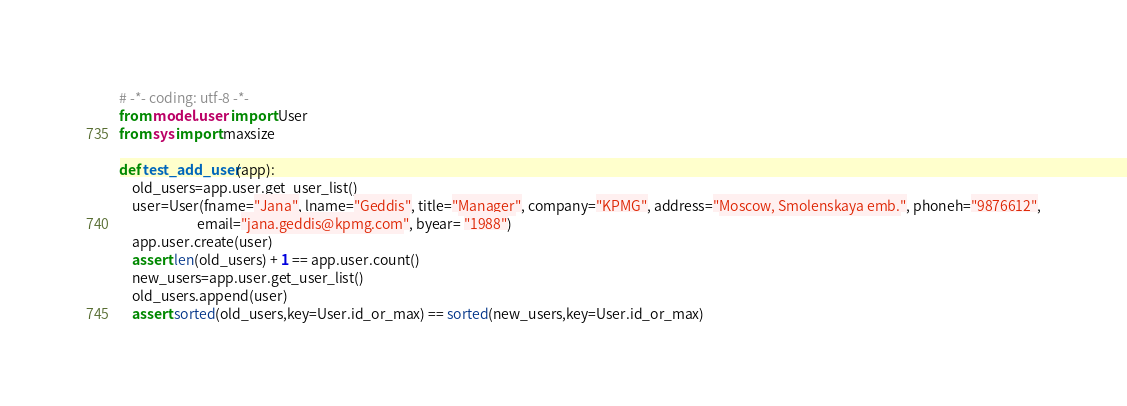<code> <loc_0><loc_0><loc_500><loc_500><_Python_># -*- coding: utf-8 -*-
from model.user import User
from sys import maxsize

def test_add_user(app):
    old_users=app.user.get_user_list()
    user=User(fname="Jana", lname="Geddis", title="Manager", company="KPMG", address="Moscow, Smolenskaya emb.", phoneh="9876612",
                         email="jana.geddis@kpmg.com", byear= "1988")
    app.user.create(user)
    assert len(old_users) + 1 == app.user.count()
    new_users=app.user.get_user_list()
    old_users.append(user)
    assert sorted(old_users,key=User.id_or_max) == sorted(new_users,key=User.id_or_max)








</code> 